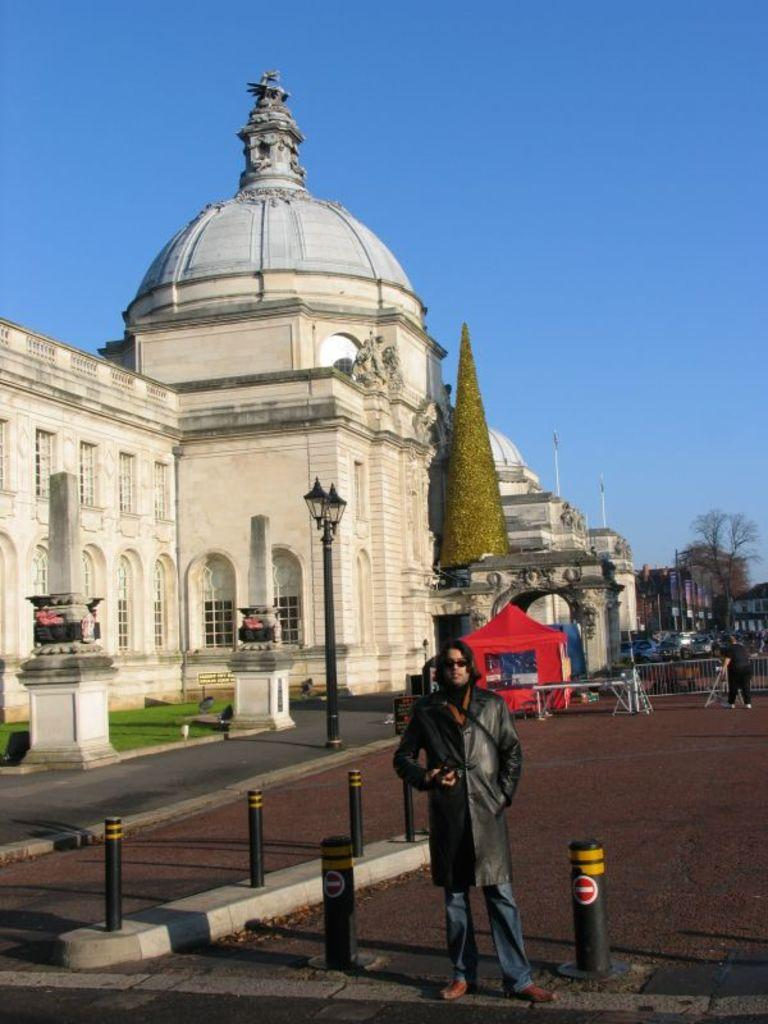What is the main subject of the image? There is a man standing in the image. What can be seen in the background of the image? There is a road, a building, a dome, trees, and the sky visible in the image. Can you describe the building in the image? The building has a dome, which is a distinct architectural feature. What type of vegetation is present in the image? There are trees in the image. Where is the nest located in the image? There is no nest present in the image. What type of lake can be seen in the image? There is no lake present in the image. 